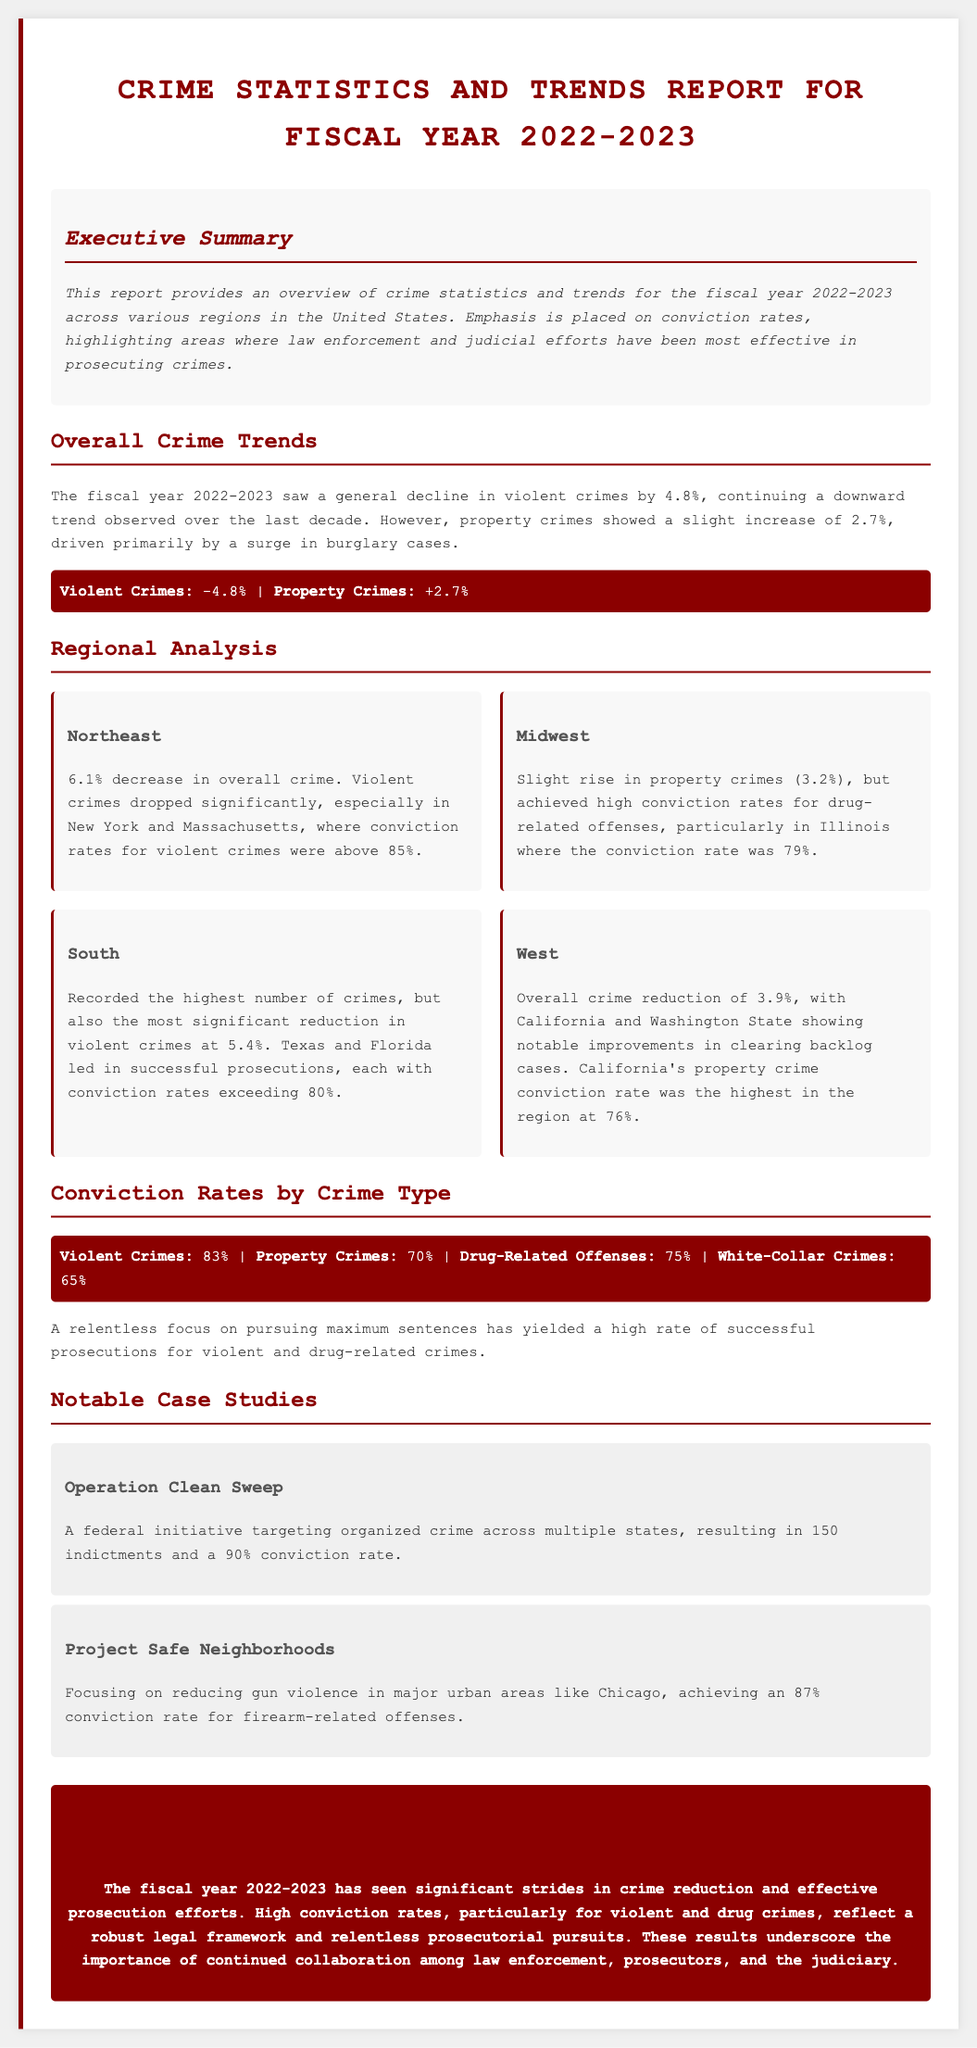What was the overall decrease in violent crimes for FY 2022-2023? The overall decrease in violent crimes is noted as 4.8%.
Answer: 4.8% What was the increase percentage in property crimes for FY 2022-2023? The document states that property crimes increased by 2.7%.
Answer: 2.7% Which region had the highest conviction rates for violent crimes? The Northeast region had conviction rates for violent crimes above 85%.
Answer: Northeast What was the conviction rate for drug-related offenses? The conviction rate for drug-related offenses was reported as 75%.
Answer: 75% Which initiative resulted in 150 indictments and a 90% conviction rate? The initiative referred to is Operation Clean Sweep.
Answer: Operation Clean Sweep How much did violent crimes decrease in the South region? The South region recorded a reduction in violent crimes of 5.4%.
Answer: 5.4% What percentage of violent crimes had a successful prosecution? The successful prosecution rate for violent crimes was 83%.
Answer: 83% Which region showed a 3.9% overall crime reduction? The West region experienced this reduction, as stated in the document.
Answer: West What was the highest property crime conviction rate in the West? California had the highest property crime conviction rate, at 76%.
Answer: 76% 